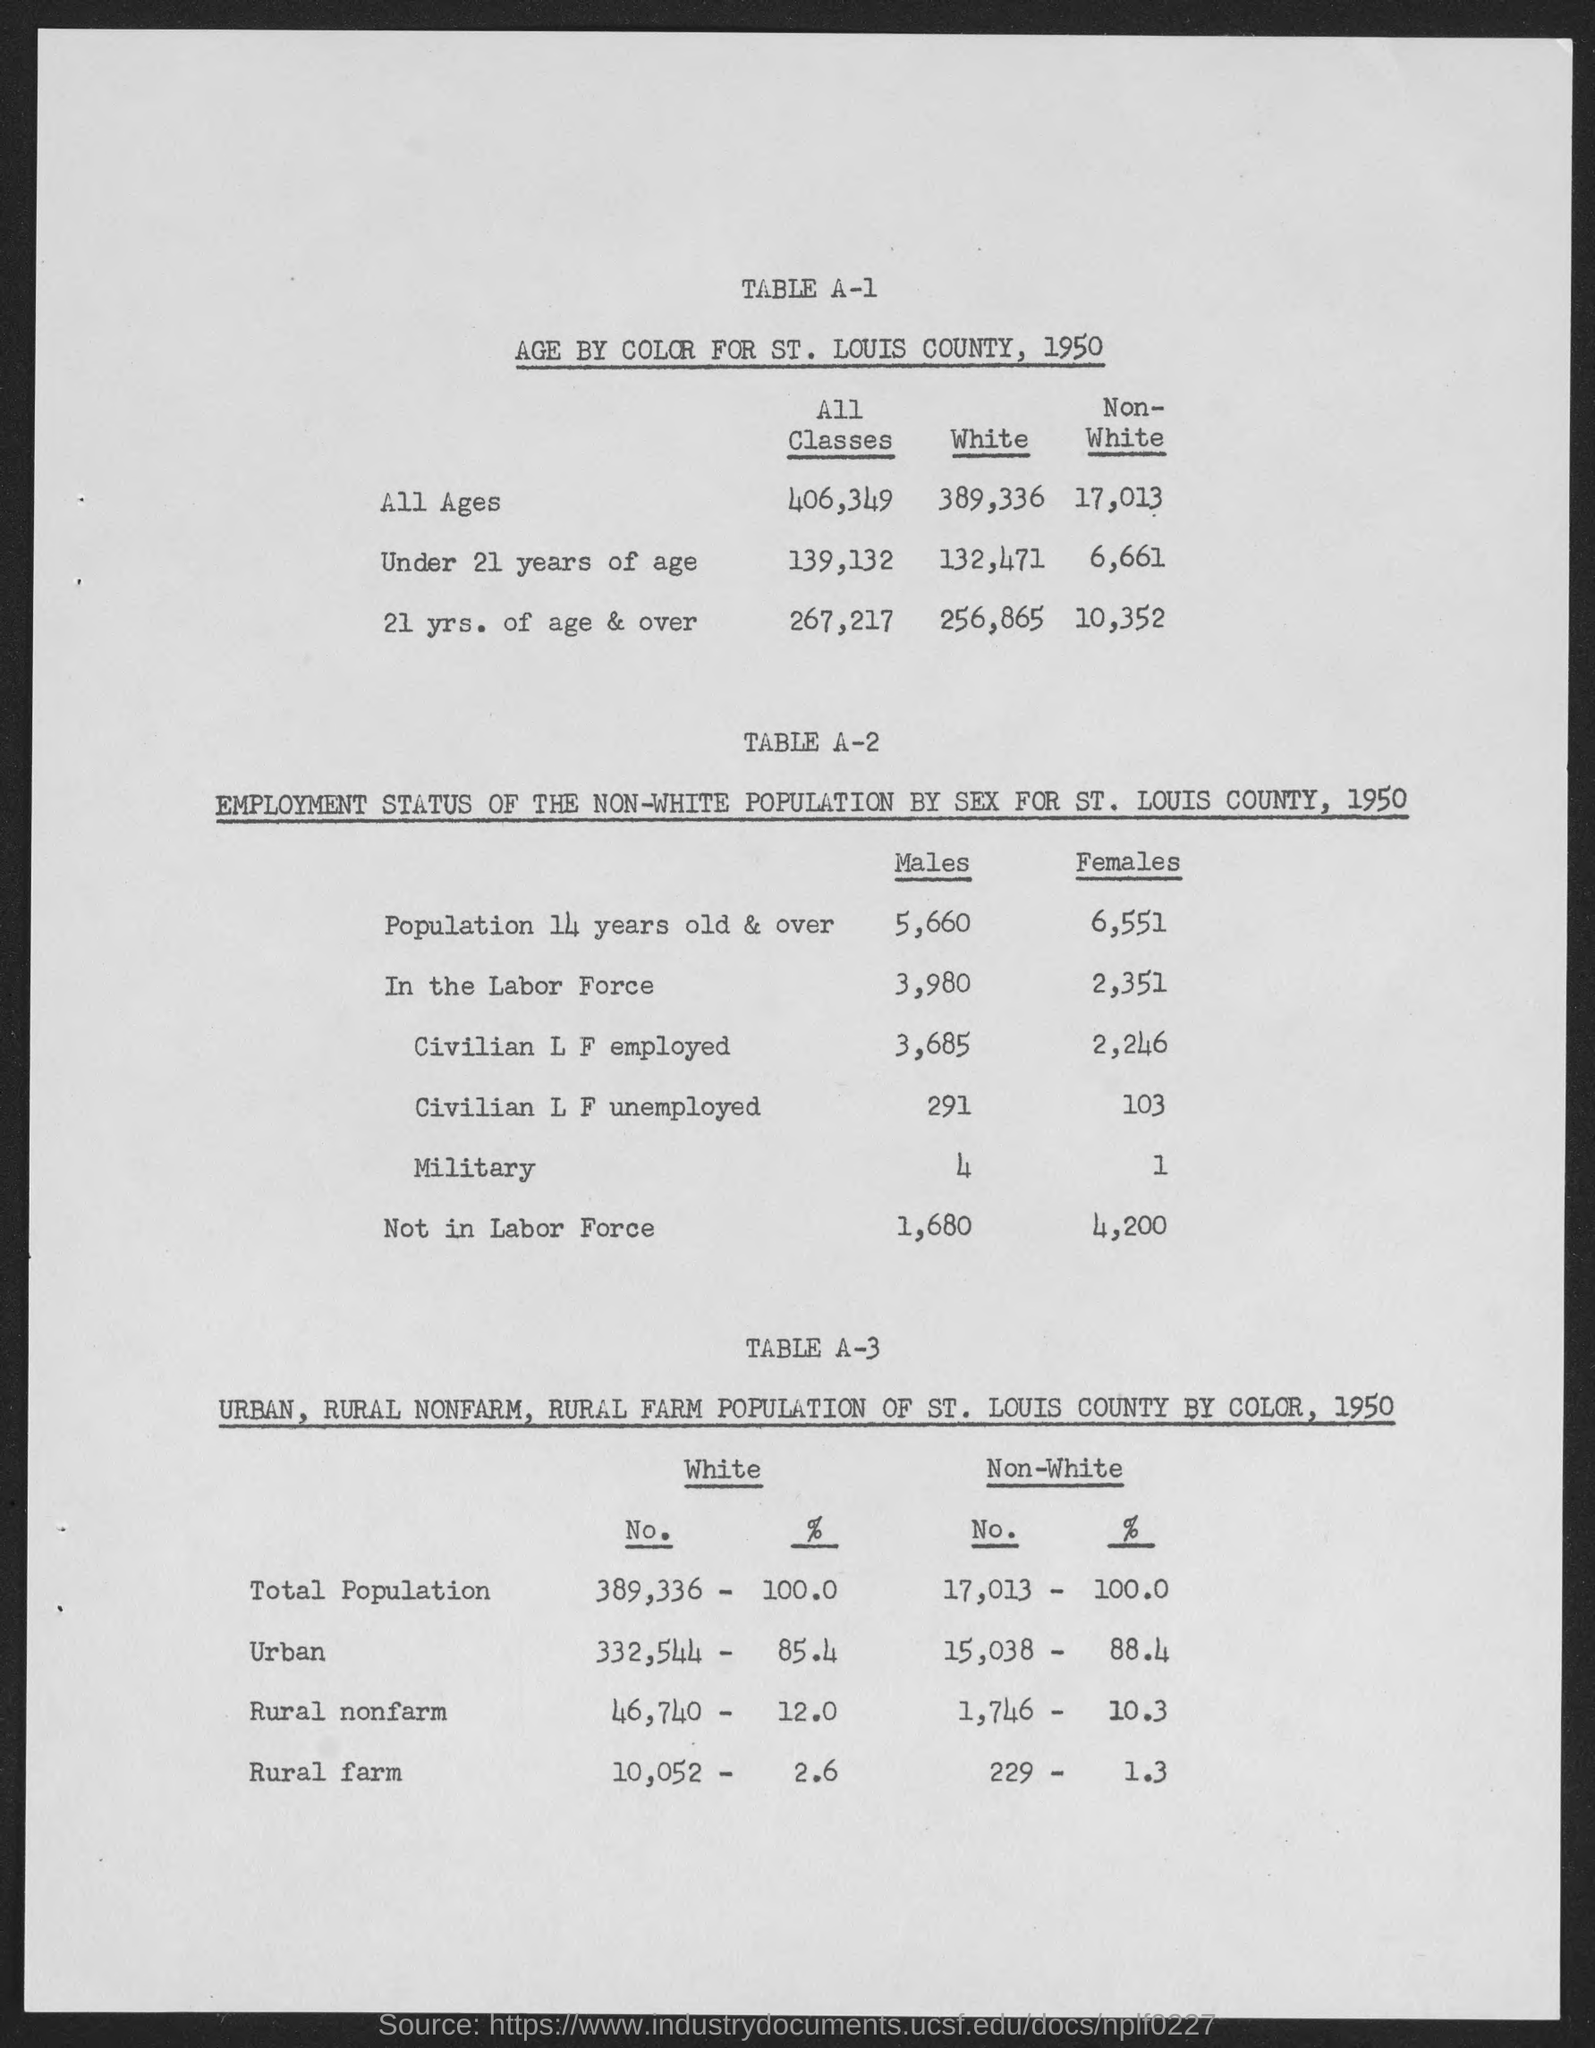What is the age by color for St. Louis county, 1950 for all ages for all classes?
Keep it short and to the point. 406,349. What is the age by color for St. Louis county, 1950 for under 21 years of age for all classes?
Offer a terse response. 139,132. What is the age by color for St. Louis county, 1950 for 21 yrs. of age and over for all classes?
Ensure brevity in your answer.  267,217. What is the age by color for St. Louis county, 1950 for all ages for white?
Provide a short and direct response. 389,336. What is the age by color for St. Louis county, 1950 for under 21 years of age for white?
Keep it short and to the point. 132,471. What is the age by color for St. Louis county, 1950 for 21 yrs. of age and over for white?
Keep it short and to the point. 256,865. What is the age by color for St. Louis county, 1950 for 21 yrs. of age and over for Non-White?
Ensure brevity in your answer.  10,352. What is the age by color for St. Louis county, 1950 for under 21 years of age for Non-white?
Make the answer very short. 6,661. What is the age by color for St. Louis county, 1950 for all ages for Non-white?
Your answer should be compact. 17,013. What are the number of males for population 14 years old & over?
Keep it short and to the point. 5,660. 